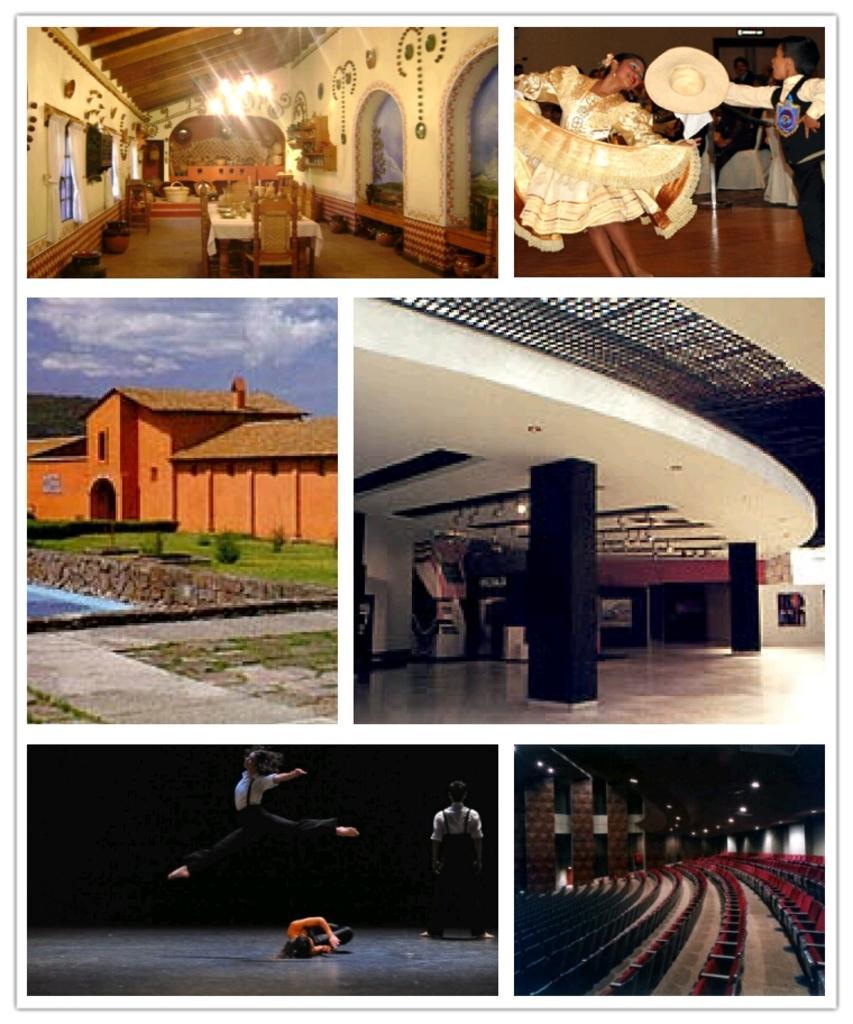How would you summarize this image in a sentence or two? It is a collage picture. In the center of the image we can see the sky, clouds, buildings, pillars, plants, grass, water and a few other objects. On the top of the image we can see two persons are performing and they are holding some objects. And we can see one building, one table, chairs, one cloth, lights, windows and a few other objects. In the bottom of the image, we can see three persons are performing. And we can see chairs, pillars, lights and a few other objects. 